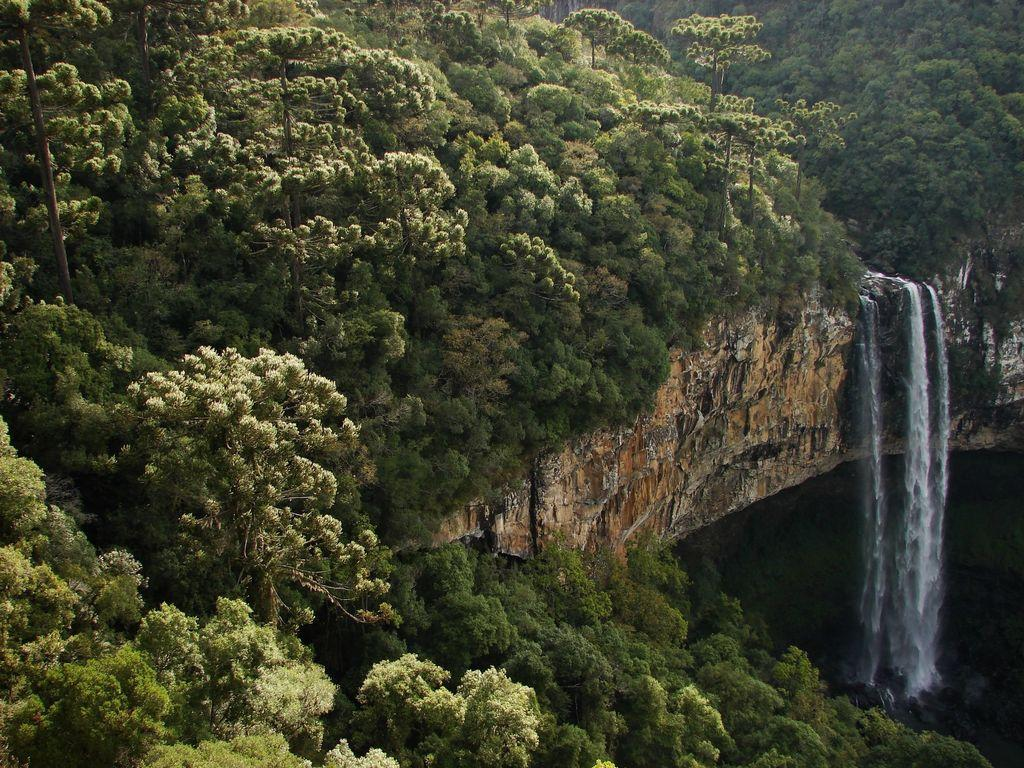What natural feature is the main subject of the picture? There is a waterfall in the picture. What type of vegetation can be seen in the picture? There are trees in the picture. What other geological features are present in the picture? There are rocks in the picture. Reasoning: Let' Let's think step by step in order to produce the conversation. We start by identifying the main subject of the image, which is the waterfall. Then, we expand the conversation to include other elements present in the image, such as trees and rocks. Each question is designed to elicit a specific detail about the image that is known from the provided facts. Absurd Question/Answer: What type of cork can be seen floating in the waterfall in the image? There is no cork present in the image; it features a waterfall, trees, and rocks. What type of rice is being cooked in the background of the image? There is no rice or cooking activity present in the image; it features a waterfall, trees, and rocks. 